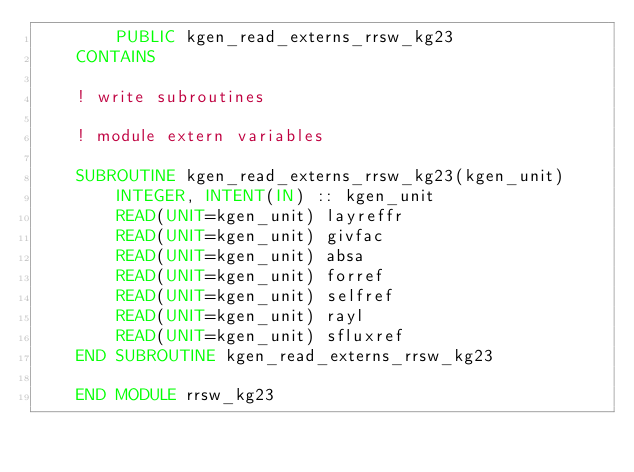Convert code to text. <code><loc_0><loc_0><loc_500><loc_500><_FORTRAN_>        PUBLIC kgen_read_externs_rrsw_kg23
    CONTAINS

    ! write subroutines

    ! module extern variables

    SUBROUTINE kgen_read_externs_rrsw_kg23(kgen_unit)
        INTEGER, INTENT(IN) :: kgen_unit
        READ(UNIT=kgen_unit) layreffr
        READ(UNIT=kgen_unit) givfac
        READ(UNIT=kgen_unit) absa
        READ(UNIT=kgen_unit) forref
        READ(UNIT=kgen_unit) selfref
        READ(UNIT=kgen_unit) rayl
        READ(UNIT=kgen_unit) sfluxref
    END SUBROUTINE kgen_read_externs_rrsw_kg23

    END MODULE rrsw_kg23
</code> 